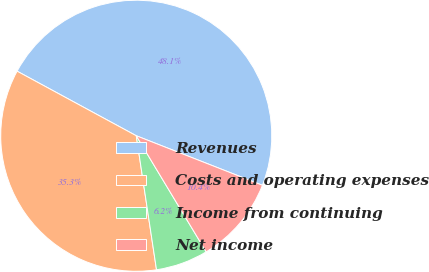Convert chart. <chart><loc_0><loc_0><loc_500><loc_500><pie_chart><fcel>Revenues<fcel>Costs and operating expenses<fcel>Income from continuing<fcel>Net income<nl><fcel>48.05%<fcel>35.29%<fcel>6.24%<fcel>10.42%<nl></chart> 